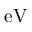Convert formula to latex. <formula><loc_0><loc_0><loc_500><loc_500>e V</formula> 